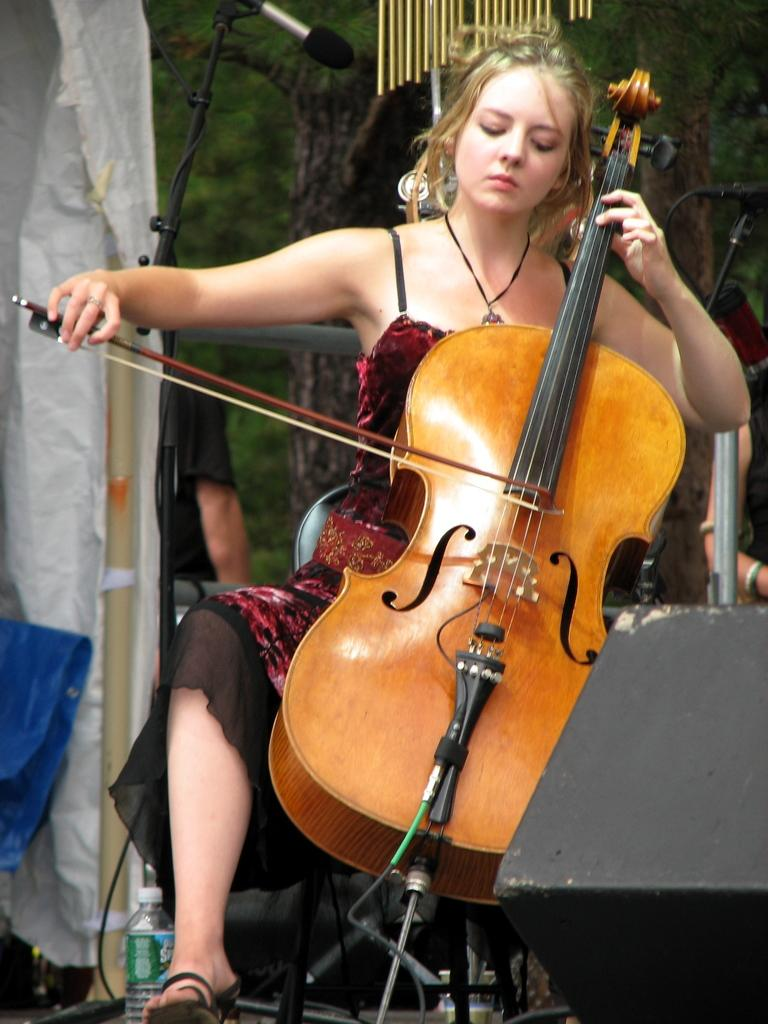Who is the main subject in the image? There is a woman in the image. What is the woman wearing? The woman is wearing a red dress. What is the woman doing in the image? The woman is sitting in a chair and playing a violin. What object is present behind the woman? There is a microphone behind her. What type of nerve damage does the woman in the image have? There is no indication of any nerve damage in the image; the woman is playing a violin and appears to be in good health. 